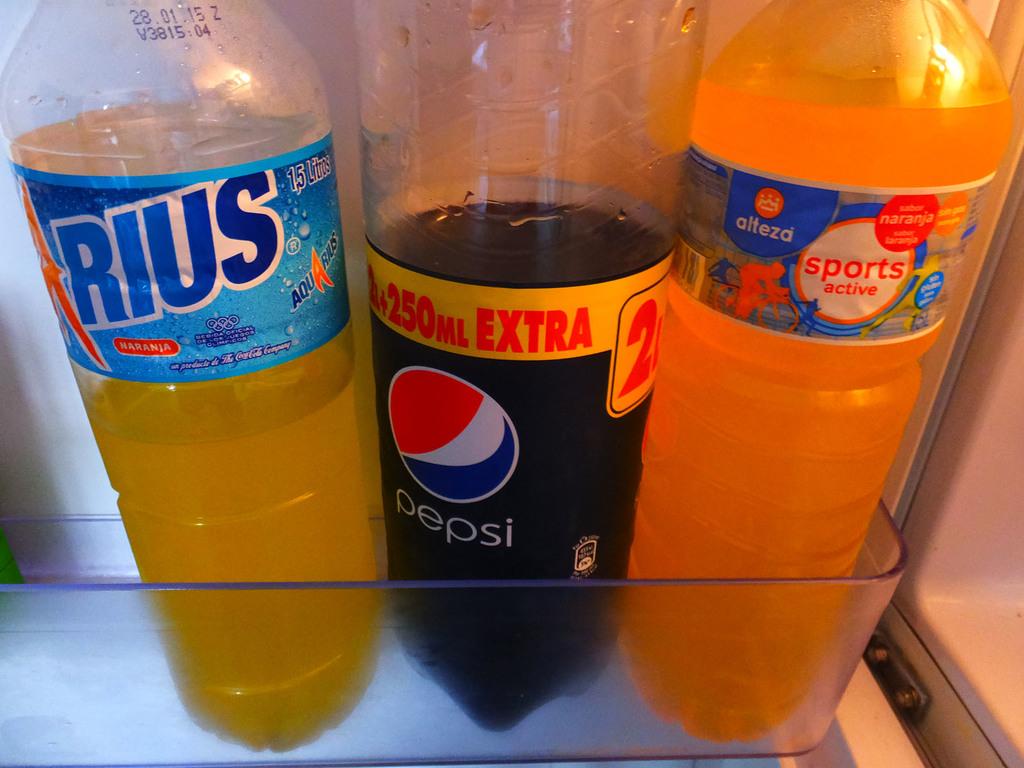How many extra ml in the pepsi?
Provide a succinct answer. 250. 